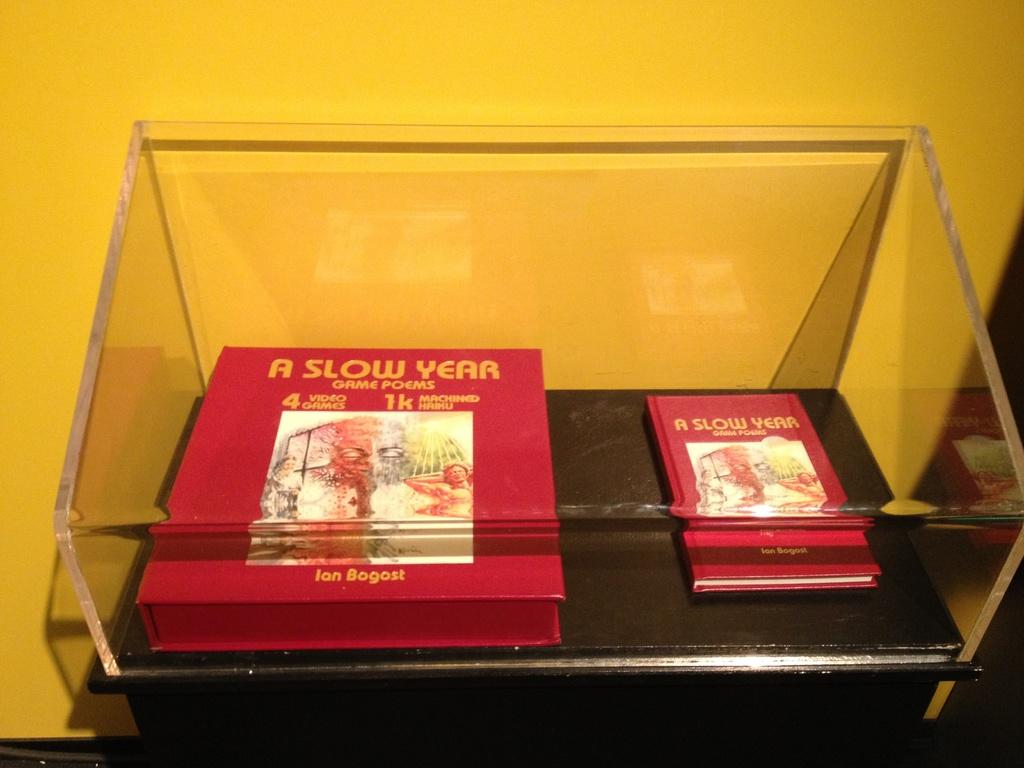Provide a one-sentence caption for the provided image. Two books with A Slow Year on the cover inside of a glass box. 